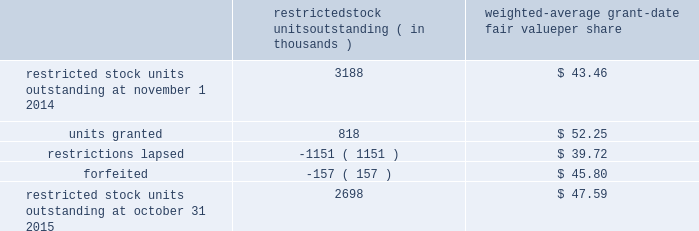Analog devices , inc .
Notes to consolidated financial statements 2014 ( continued ) a summary of the company 2019s restricted stock unit award activity as of october 31 , 2015 and changes during the fiscal year then ended is presented below : restricted stock units outstanding ( in thousands ) weighted- average grant- date fair value per share .
As of october 31 , 2015 , there was $ 108.8 million of total unrecognized compensation cost related to unvested share- based awards comprised of stock options and restricted stock units .
That cost is expected to be recognized over a weighted- average period of 1.3 years .
The total grant-date fair value of shares that vested during fiscal 2015 , 2014 and 2013 was approximately $ 65.6 million , $ 57.4 million and $ 63.9 million , respectively .
Common stock repurchase program the company 2019s common stock repurchase program has been in place since august 2004 .
In the aggregate , the board of directors have authorized the company to repurchase $ 5.6 billion of the company 2019s common stock under the program .
Under the program , the company may repurchase outstanding shares of its common stock from time to time in the open market and through privately negotiated transactions .
Unless terminated earlier by resolution of the company 2019s board of directors , the repurchase program will expire when the company has repurchased all shares authorized under the program .
As of october 31 , 2015 , the company had repurchased a total of approximately 140.7 million shares of its common stock for approximately $ 5.0 billion under this program .
An additional $ 544.5 million remains available for repurchase of shares under the current authorized program .
The repurchased shares are held as authorized but unissued shares of common stock .
The company also , from time to time , repurchases shares in settlement of employee minimum tax withholding obligations due upon the vesting of restricted stock units or the exercise of stock options .
The withholding amount is based on the employees minimum statutory withholding requirement .
Any future common stock repurchases will be dependent upon several factors , including the company's financial performance , outlook , liquidity and the amount of cash the company has available in the united states .
Preferred stock the company has 471934 authorized shares of $ 1.00 par value preferred stock , none of which is issued or outstanding .
The board of directors is authorized to fix designations , relative rights , preferences and limitations on the preferred stock at the time of issuance .
Industry , segment and geographic information the company operates and tracks its results in one reportable segment based on the aggregation of six operating segments .
The company designs , develops , manufactures and markets a broad range of integrated circuits ( ics ) .
The chief executive officer has been identified as the company's chief operating decision maker .
The company has determined that all of the company's operating segments share the following similar economic characteristics , and therefore meet the criteria established for operating segments to be aggregated into one reportable segment , namely : 2022 the primary source of revenue for each operating segment is the sale of integrated circuits .
2022 the integrated circuits sold by each of the company's operating segments are manufactured using similar semiconductor manufacturing processes and raw materials in either the company 2019s own production facilities or by third-party wafer fabricators using proprietary processes .
2022 the company sells its products to tens of thousands of customers worldwide .
Many of these customers use products spanning all operating segments in a wide range of applications .
2022 the integrated circuits marketed by each of the company's operating segments are sold globally through a direct sales force , third-party distributors , independent sales representatives and via our website to the same types of customers .
All of the company's operating segments share a similar long-term financial model as they have similar economic characteristics .
The causes for variation in operating and financial performance are the same among the company's operating segments and include factors such as ( i ) life cycle and price and cost fluctuations , ( ii ) number of competitors , ( iii ) product .
What is the growth rate in the fair value of the total restricted stock units outstanding in 2015? 
Computations: (((2698 * 47.59) - (3188 * 43.46)) / (3188 * 43.46))
Answer: -0.07328. 